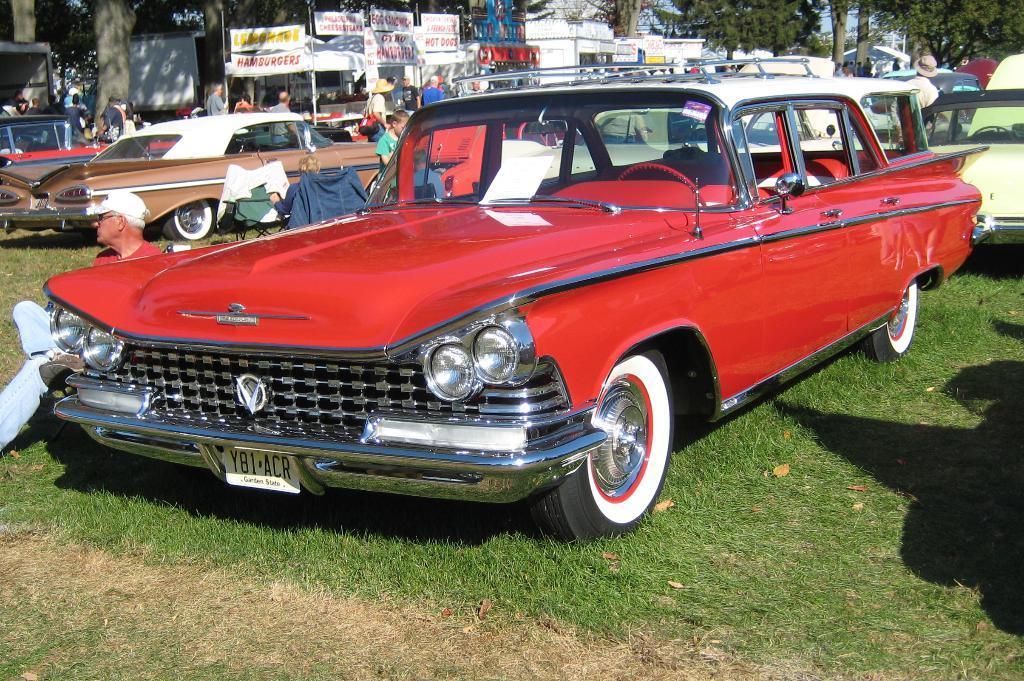Can you describe this image briefly? In this picture we can see there are some vehicles parked on the path and some people are standing on the path and some people are sitting on chairs. Behind the people there are stalls, boards, banners, and trees and sky. 